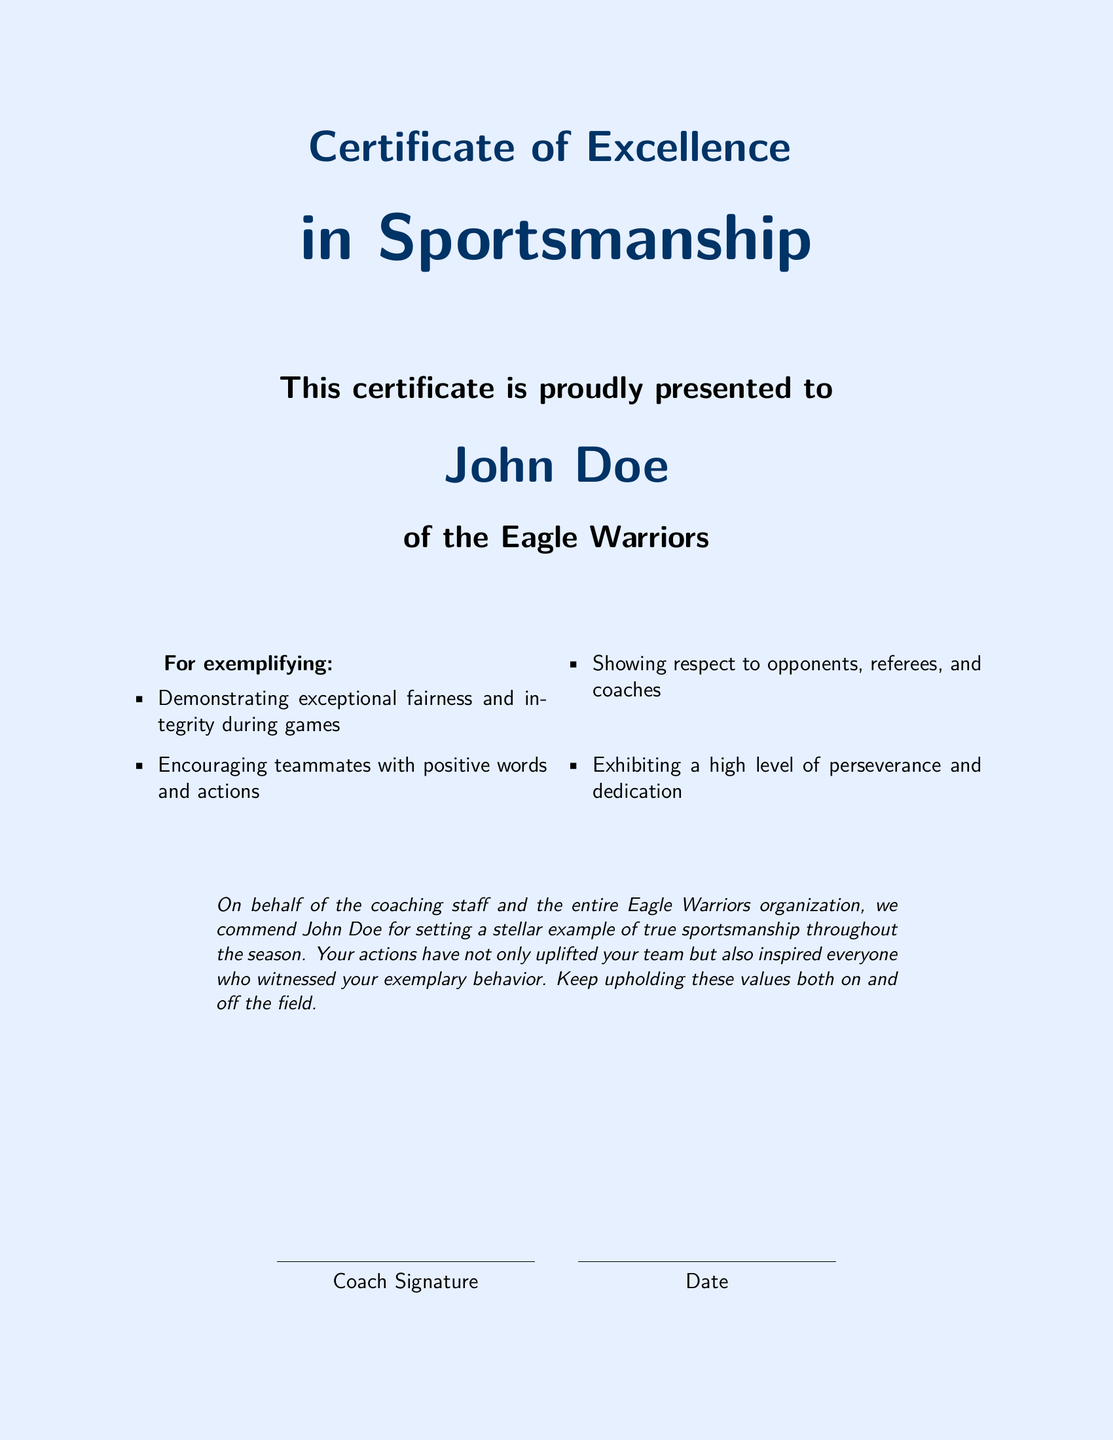What is the title of the certificate? The title of the certificate is prominently displayed at the top of the document, which is "Certificate of Excellence in Sportsmanship."
Answer: Certificate of Excellence in Sportsmanship What is the name of the recipient? The name of the recipient is indicated in a larger font in the center of the document, which is "John Doe."
Answer: John Doe What is the name of the team? The name of the team is included in the certificate, which is "Eagle Warriors."
Answer: Eagle Warriors What qualities are exemplified by the recipient? The document lists specific qualities exemplified by the recipient in a bulleted format, such as fairness and integrity.
Answer: Fairness and integrity How is the recipient commended by the organization? The commendation is a statement from the coaching staff, recognizing the exemplary behavior of the recipient.
Answer: Commended for setting a stellar example Who signs the certificate? The certificate includes a space for the coach's signature.
Answer: Coach Signature What design elements are highlighted in the certificate? The design elements focus on fairness and integrity, accompanied by sports-related graphics.
Answer: Fairness and integrity What type of award is this document? The document is a formal acknowledgment of significant behavior in sportsmanship.
Answer: Award What is the document's page color? The background color of the document is specified in the design, which is light blue.
Answer: Light blue 